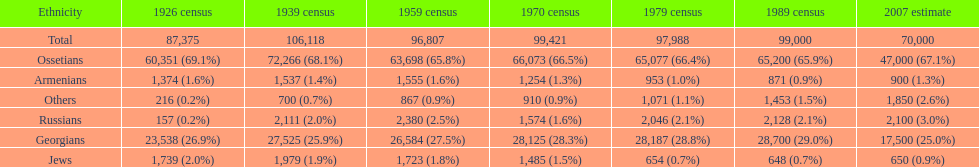Which population had the most people in 1926? Ossetians. 